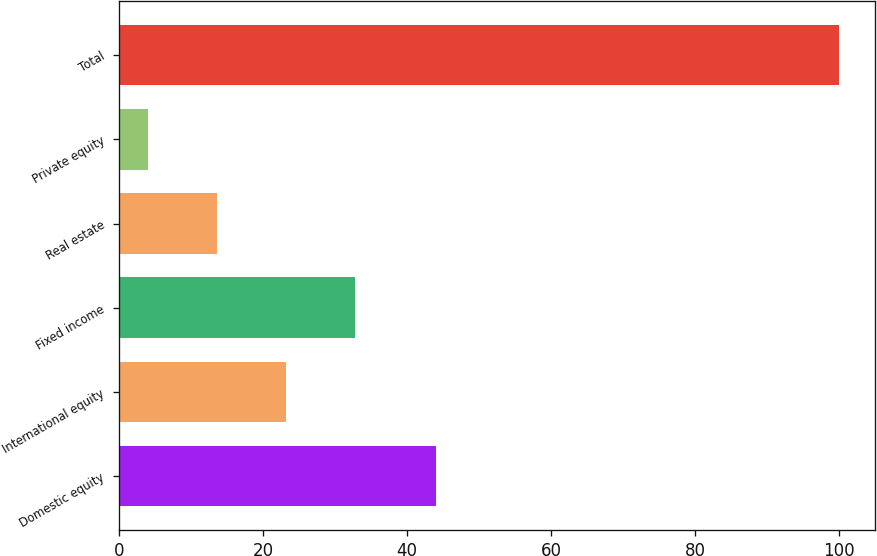Convert chart. <chart><loc_0><loc_0><loc_500><loc_500><bar_chart><fcel>Domestic equity<fcel>International equity<fcel>Fixed income<fcel>Real estate<fcel>Private equity<fcel>Total<nl><fcel>44<fcel>23.2<fcel>32.8<fcel>13.6<fcel>4<fcel>100<nl></chart> 